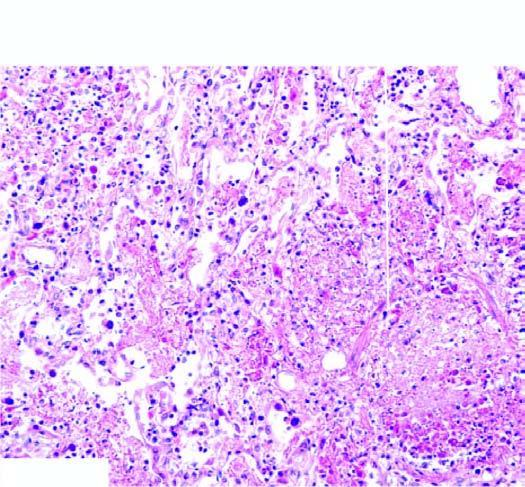s gamna-gandy body interstitial inflammation?
Answer the question using a single word or phrase. No 